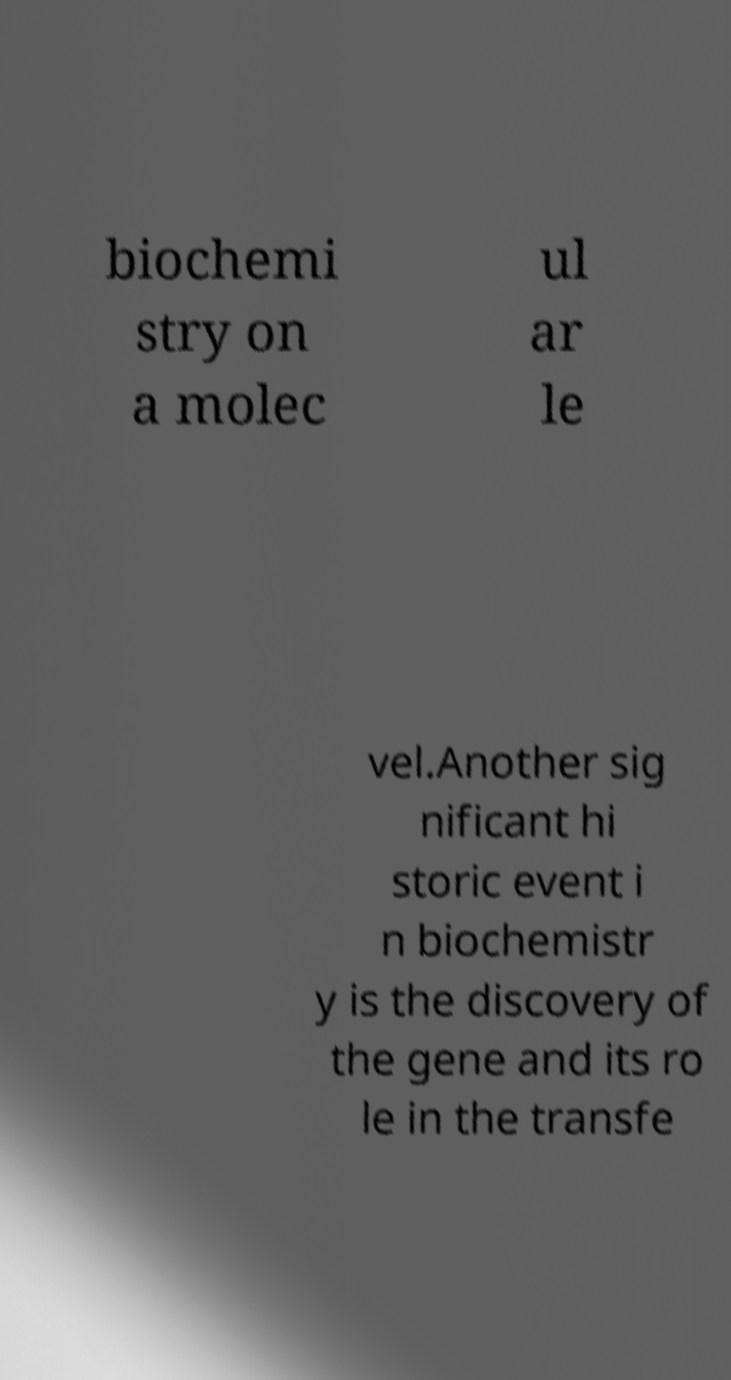Could you assist in decoding the text presented in this image and type it out clearly? biochemi stry on a molec ul ar le vel.Another sig nificant hi storic event i n biochemistr y is the discovery of the gene and its ro le in the transfe 